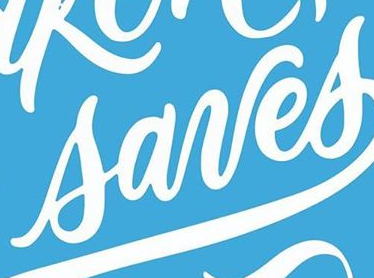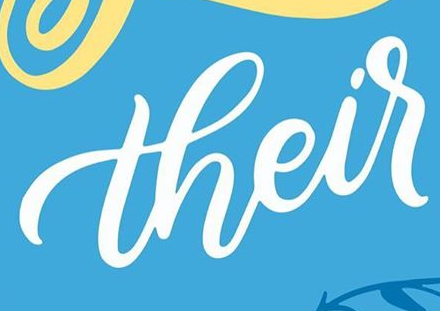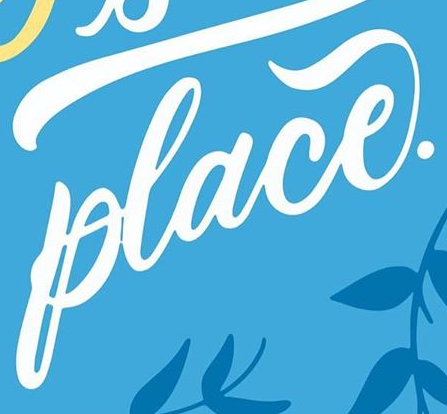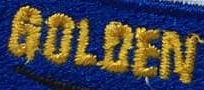What words can you see in these images in sequence, separated by a semicolon? sanes; their; place.; GOLOEN 